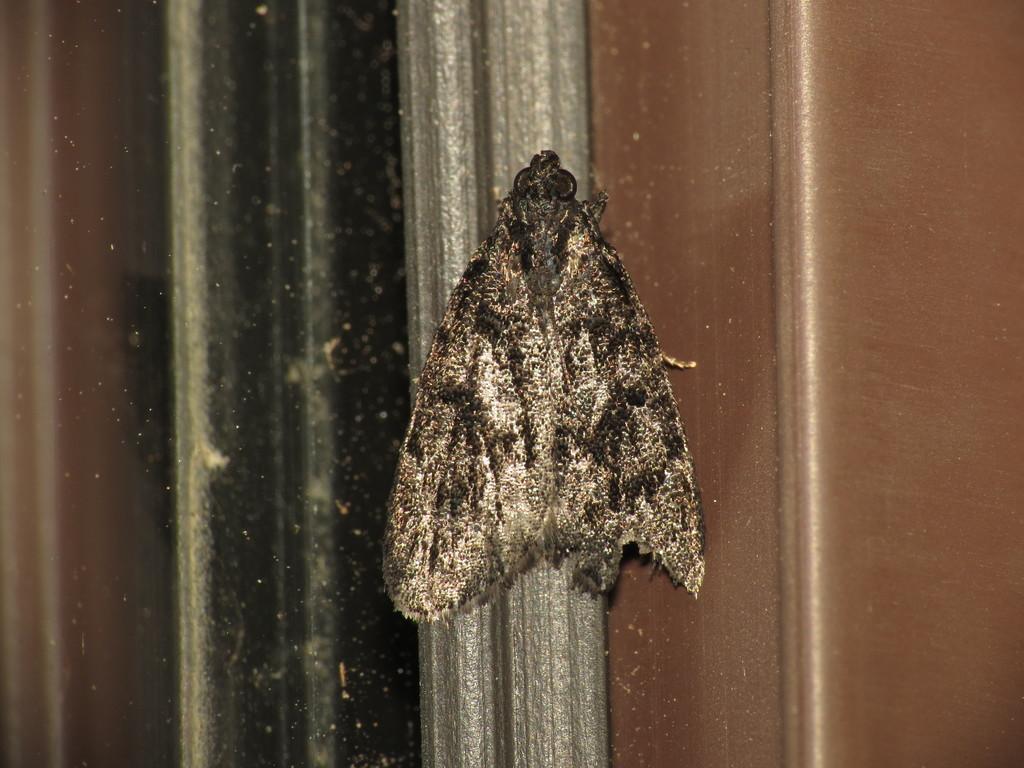Can you describe this image briefly? In this image I can see an insect which is black and cream in color on the grey, brown and black colored object. 